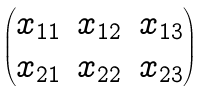<formula> <loc_0><loc_0><loc_500><loc_500>\begin{pmatrix} x _ { 1 1 } & x _ { 1 2 } & x _ { 1 3 } \\ x _ { 2 1 } & x _ { 2 2 } & x _ { 2 3 } \end{pmatrix}</formula> 